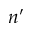<formula> <loc_0><loc_0><loc_500><loc_500>n ^ { \prime }</formula> 